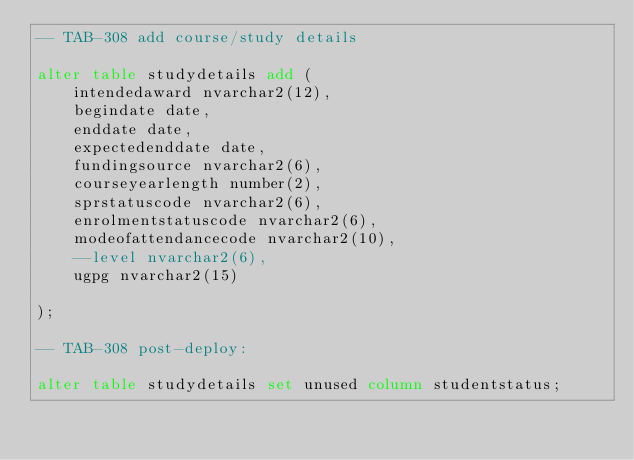Convert code to text. <code><loc_0><loc_0><loc_500><loc_500><_SQL_>-- TAB-308 add course/study details

alter table studydetails add (
	intendedaward nvarchar2(12),
	begindate date,
	enddate date,
	expectedenddate date,
	fundingsource nvarchar2(6),
	courseyearlength number(2),
	sprstatuscode nvarchar2(6),
	enrolmentstatuscode nvarchar2(6),
	modeofattendancecode nvarchar2(10),
	--level nvarchar2(6),
	ugpg nvarchar2(15)
	
);

-- TAB-308 post-deploy:

alter table studydetails set unused column studentstatus;
</code> 